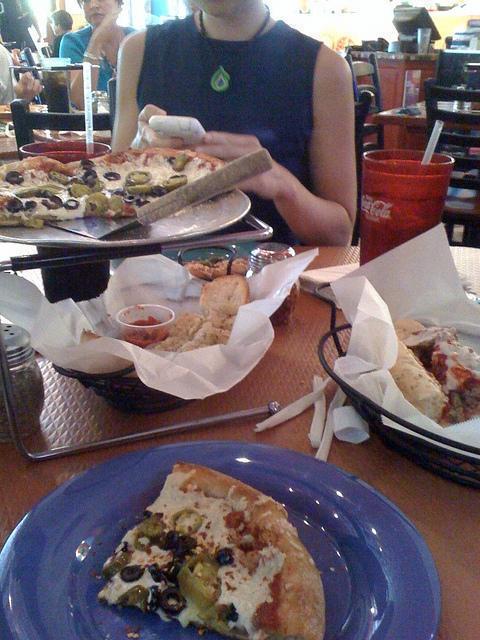What is in the thing with coke?
Select the correct answer and articulate reasoning with the following format: 'Answer: answer
Rationale: rationale.'
Options: Fork, straw, pencil, spoon. Answer: straw.
Rationale: There is a glass of coke with a straw in it. 